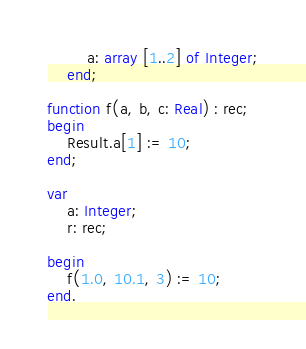<code> <loc_0><loc_0><loc_500><loc_500><_Pascal_>        a: array [1..2] of Integer;
    end;

function f(a, b, c: Real) : rec;
begin
    Result.a[1] := 10;
end;

var
    a: Integer;
    r: rec;

begin
    f(1.0, 10.1, 3) := 10;
end.</code> 